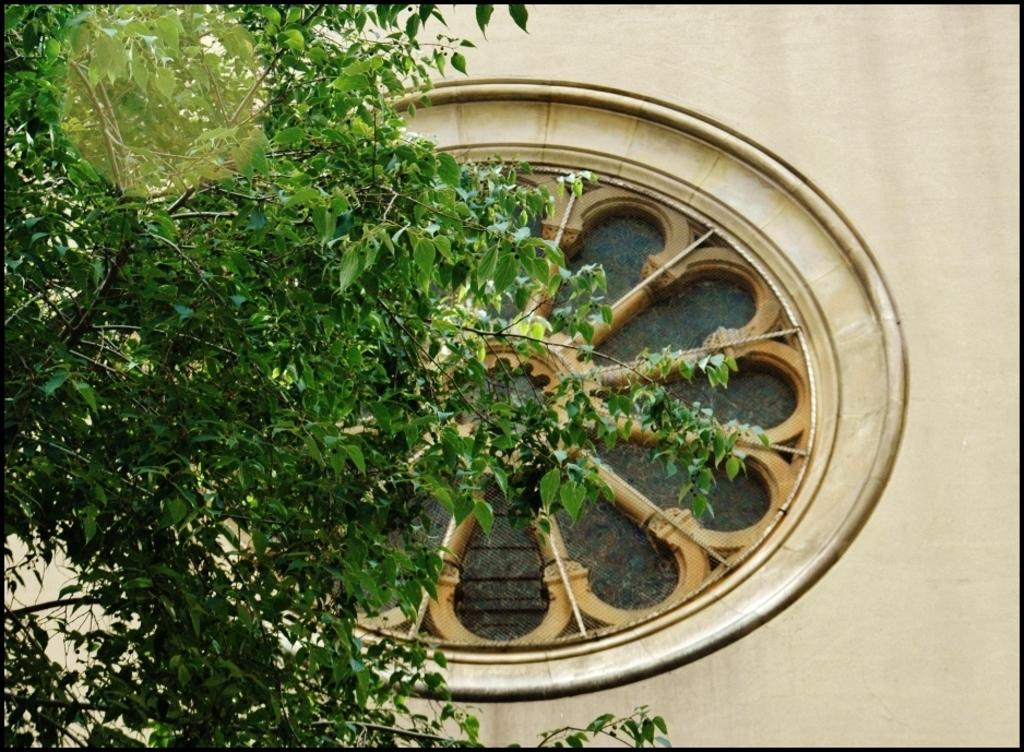What is located on the left side of the image? There is a tree in the foreground of the image. What is the shape of the object near the tree? There is a round shaped light shade in the foreground of the image. What can be seen in the background of the image? There is a wall in the background of the image. What type of structure is on the wall in the background? There is a wheel-like structure on the wall in the background. What type of ornament is hanging from the tree in the image? There is no ornament hanging from the tree in the image; it is a tree with a round shaped light shade nearby. 